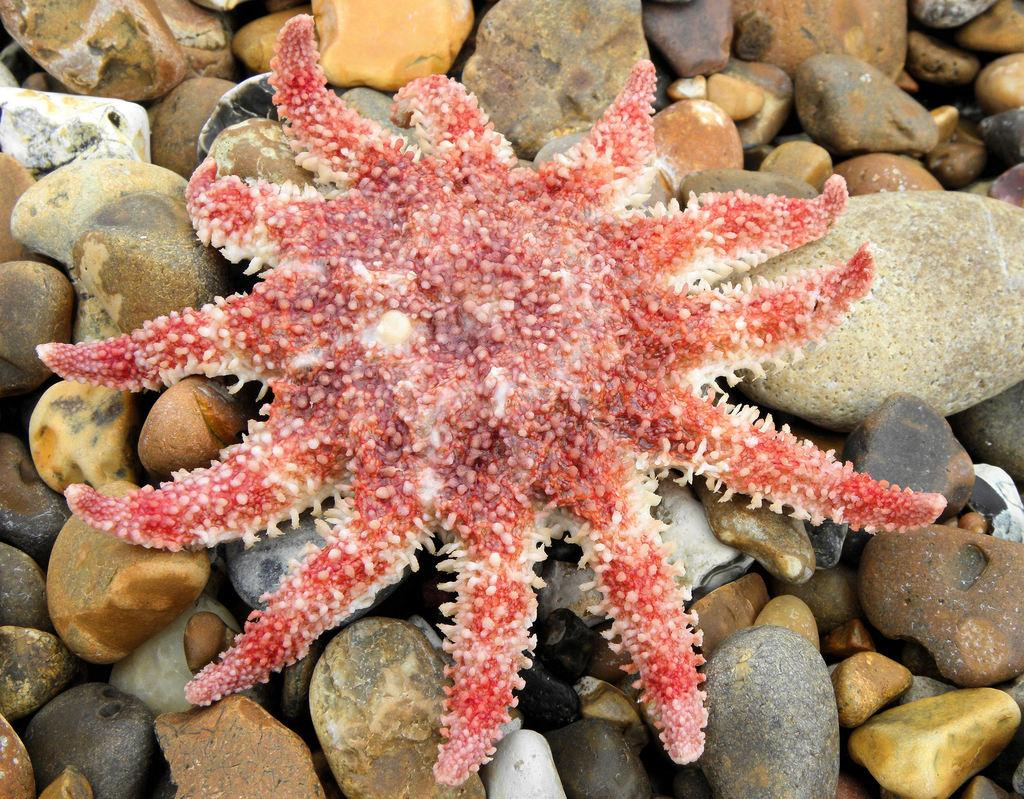What type of animals can be seen in the image? There are fish in the image. What other objects or elements are present in the image? There are stones in the image. What type of apparel is being worn by the fish in the image? There is no apparel present in the image, as it features fish and stones. 